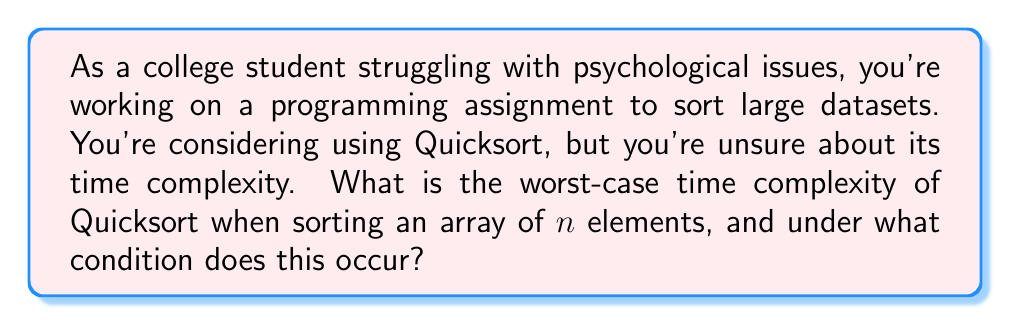Help me with this question. Let's break this down step-by-step:

1) Quicksort is a divide-and-conquer algorithm that works by selecting a 'pivot' element and partitioning the array around it.

2) In the best and average cases, Quicksort has a time complexity of $O(n \log n)$, where $n$ is the number of elements.

3) However, the worst-case scenario occurs when the pivot chosen at each step is either the smallest or largest element in the array.

4) In this case, one partition is always empty, and the other contains all elements except the pivot.

5) This leads to a recurrence relation:
   $T(n) = T(n-1) + O(n)$

6) Solving this recurrence relation:
   $T(n) = T(n-1) + cn$
   $= (T(n-2) + c(n-1)) + cn$
   $= T(n-3) + c(n-2) + c(n-1) + cn$
   $= T(1) + c(2 + 3 + ... + (n-1) + n)$
   $= T(1) + c(\frac{n(n+1)}{2} - 1)$

7) This simplifies to $O(n^2)$

8) This worst-case scenario occurs when the input array is already sorted (in either ascending or descending order), and the first or last element is always chosen as the pivot.

Understanding this can help manage stress related to algorithm performance in your programming assignments.
Answer: The worst-case time complexity of Quicksort is $O(n^2)$, which occurs when the input array is already sorted and the pivot is always chosen as the first or last element. 